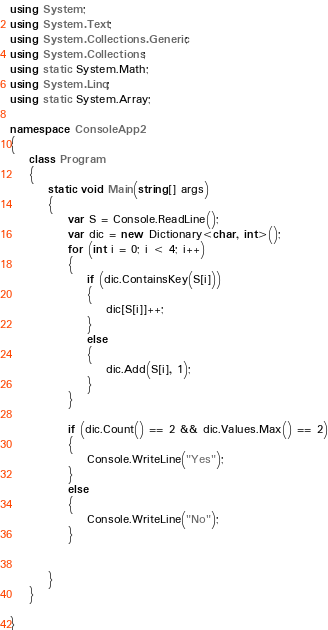Convert code to text. <code><loc_0><loc_0><loc_500><loc_500><_C#_>using System;
using System.Text;
using System.Collections.Generic;
using System.Collections;
using static System.Math;
using System.Linq;
using static System.Array;

namespace ConsoleApp2
{
    class Program
    {
        static void Main(string[] args)
        {
            var S = Console.ReadLine();
            var dic = new Dictionary<char, int>();
            for (int i = 0; i < 4; i++)
            {
                if (dic.ContainsKey(S[i]))
                {
                    dic[S[i]]++;
                }
                else
                {
                    dic.Add(S[i], 1);
                }
            }

            if (dic.Count() == 2 && dic.Values.Max() == 2)
            {
                Console.WriteLine("Yes");
            }
            else
            {
                Console.WriteLine("No");
            }
            
            
        }
    }

}
</code> 